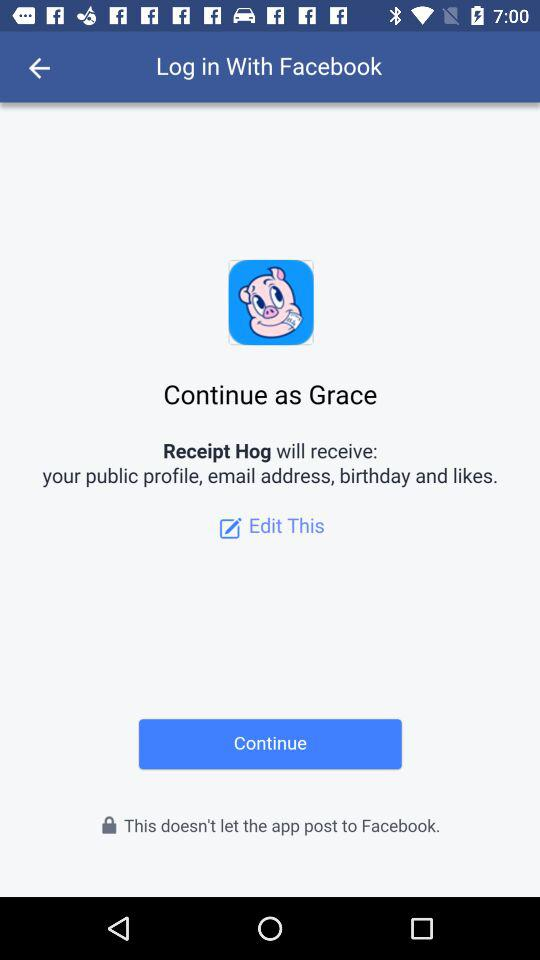What is the name of the user? The name of the user is Grace. 